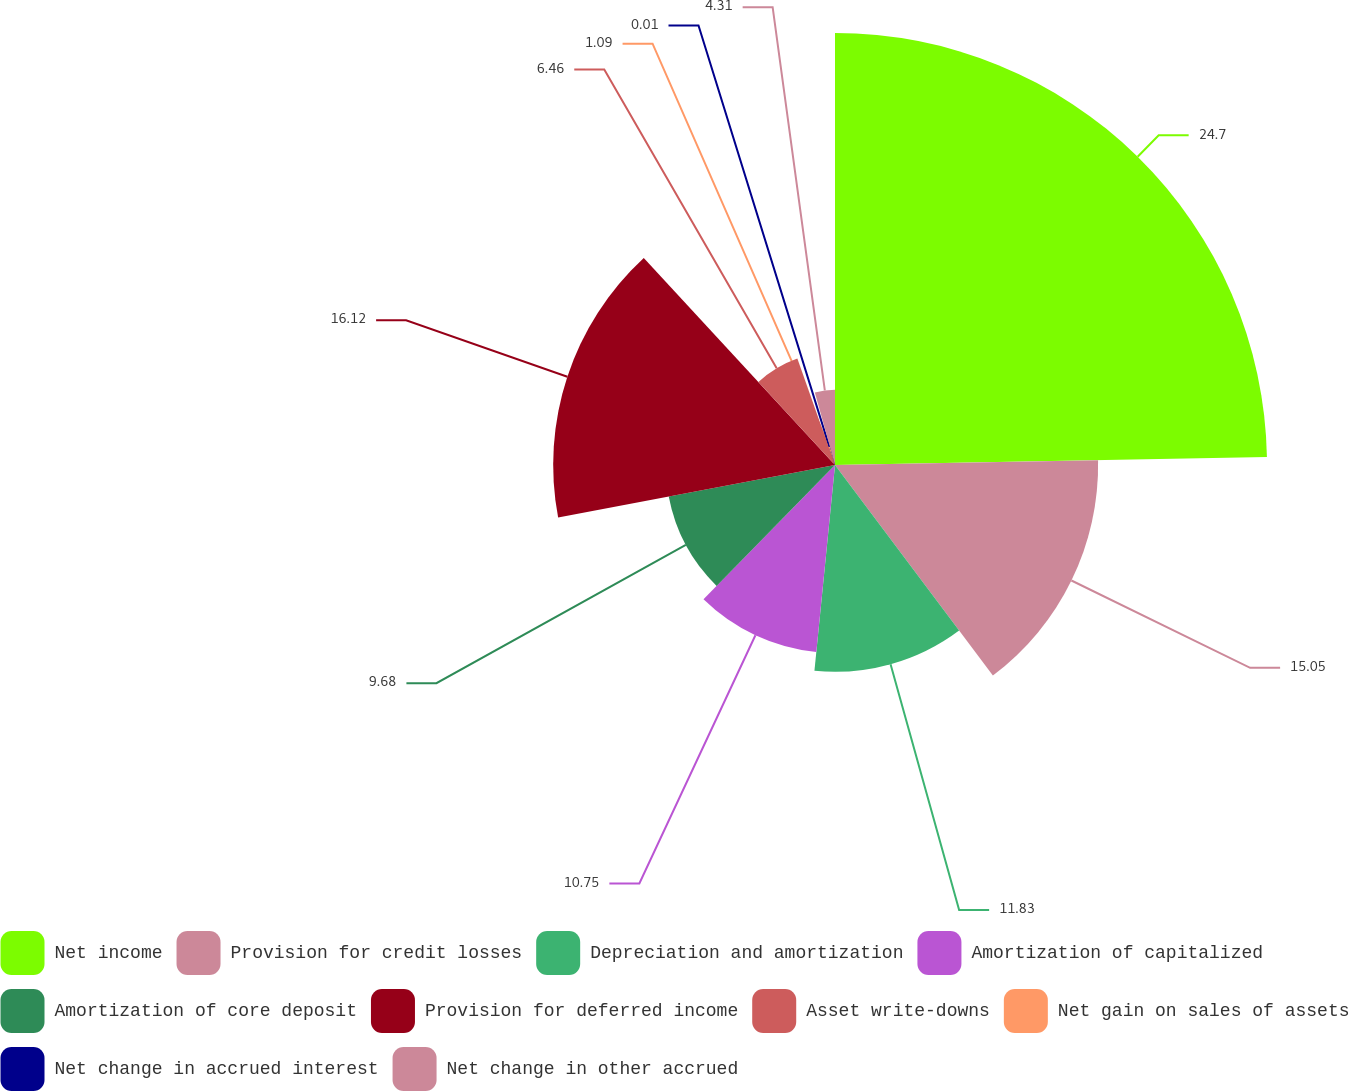Convert chart. <chart><loc_0><loc_0><loc_500><loc_500><pie_chart><fcel>Net income<fcel>Provision for credit losses<fcel>Depreciation and amortization<fcel>Amortization of capitalized<fcel>Amortization of core deposit<fcel>Provision for deferred income<fcel>Asset write-downs<fcel>Net gain on sales of assets<fcel>Net change in accrued interest<fcel>Net change in other accrued<nl><fcel>24.71%<fcel>15.05%<fcel>11.83%<fcel>10.75%<fcel>9.68%<fcel>16.12%<fcel>6.46%<fcel>1.09%<fcel>0.01%<fcel>4.31%<nl></chart> 